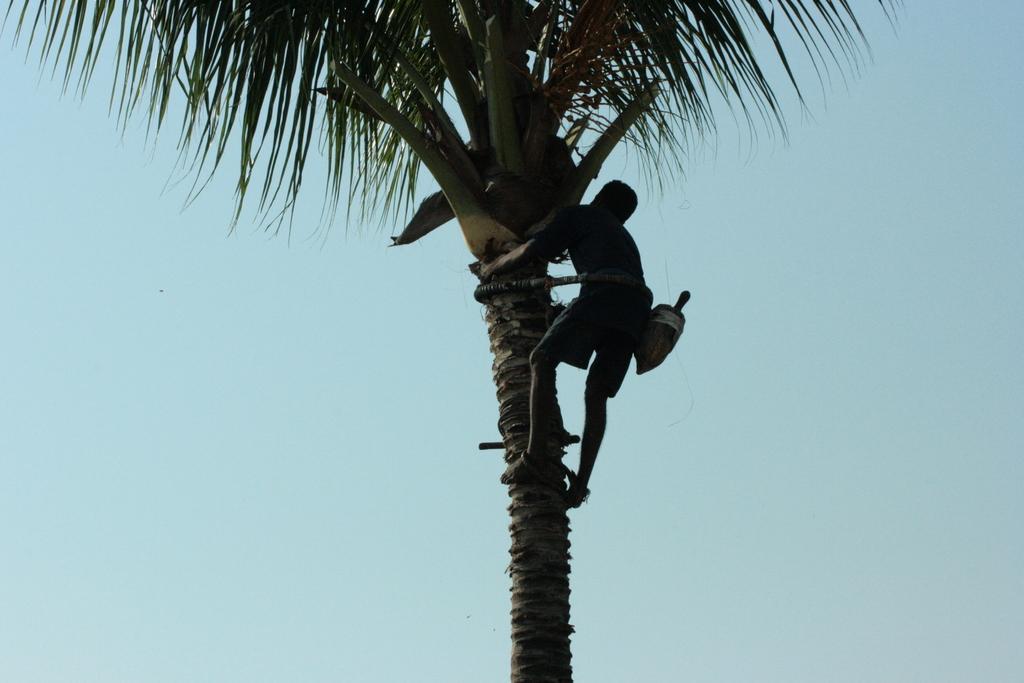Describe this image in one or two sentences. In this image we can see there is a person climbing a coconut tree. In the background there is the sky. 